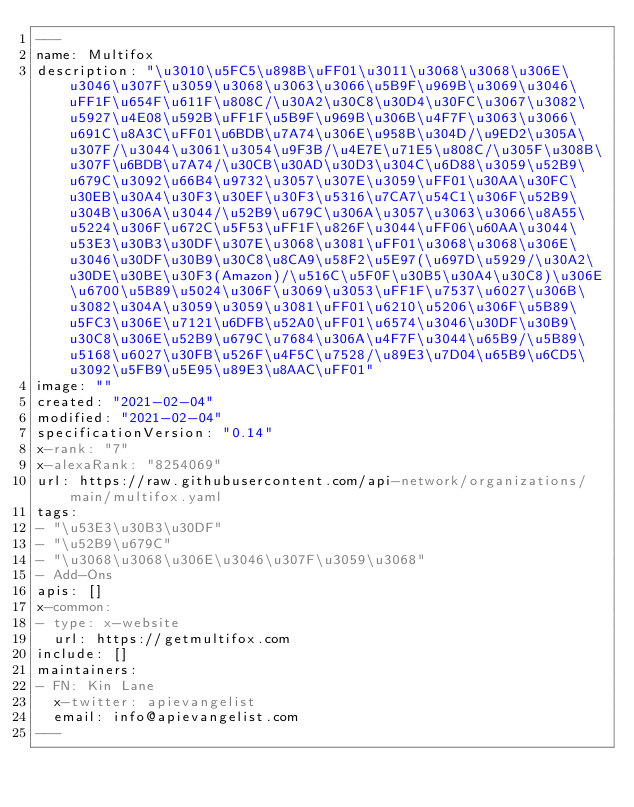<code> <loc_0><loc_0><loc_500><loc_500><_YAML_>---
name: Multifox
description: "\u3010\u5FC5\u898B\uFF01\u3011\u3068\u3068\u306E\u3046\u307F\u3059\u3068\u3063\u3066\u5B9F\u969B\u3069\u3046\uFF1F\u654F\u611F\u808C/\u30A2\u30C8\u30D4\u30FC\u3067\u3082\u5927\u4E08\u592B\uFF1F\u5B9F\u969B\u306B\u4F7F\u3063\u3066\u691C\u8A3C\uFF01\u6BDB\u7A74\u306E\u958B\u304D/\u9ED2\u305A\u307F/\u3044\u3061\u3054\u9F3B/\u4E7E\u71E5\u808C/\u305F\u308B\u307F\u6BDB\u7A74/\u30CB\u30AD\u30D3\u304C\u6D88\u3059\u52B9\u679C\u3092\u66B4\u9732\u3057\u307E\u3059\uFF01\u30AA\u30FC\u30EB\u30A4\u30F3\u30EF\u30F3\u5316\u7CA7\u54C1\u306F\u52B9\u304B\u306A\u3044/\u52B9\u679C\u306A\u3057\u3063\u3066\u8A55\u5224\u306F\u672C\u5F53\uFF1F\u826F\u3044\uFF06\u60AA\u3044\u53E3\u30B3\u30DF\u307E\u3068\u3081\uFF01\u3068\u3068\u306E\u3046\u30DF\u30B9\u30C8\u8CA9\u58F2\u5E97(\u697D\u5929/\u30A2\u30DE\u30BE\u30F3(Amazon)/\u516C\u5F0F\u30B5\u30A4\u30C8)\u306E\u6700\u5B89\u5024\u306F\u3069\u3053\uFF1F\u7537\u6027\u306B\u3082\u304A\u3059\u3059\u3081\uFF01\u6210\u5206\u306F\u5B89\u5FC3\u306E\u7121\u6DFB\u52A0\uFF01\u6574\u3046\u30DF\u30B9\u30C8\u306E\u52B9\u679C\u7684\u306A\u4F7F\u3044\u65B9/\u5B89\u5168\u6027\u30FB\u526F\u4F5C\u7528/\u89E3\u7D04\u65B9\u6CD5\u3092\u5FB9\u5E95\u89E3\u8AAC\uFF01"
image: ""
created: "2021-02-04"
modified: "2021-02-04"
specificationVersion: "0.14"
x-rank: "7"
x-alexaRank: "8254069"
url: https://raw.githubusercontent.com/api-network/organizations/main/multifox.yaml
tags:
- "\u53E3\u30B3\u30DF"
- "\u52B9\u679C"
- "\u3068\u3068\u306E\u3046\u307F\u3059\u3068"
- Add-Ons
apis: []
x-common:
- type: x-website
  url: https://getmultifox.com
include: []
maintainers:
- FN: Kin Lane
  x-twitter: apievangelist
  email: info@apievangelist.com
---</code> 